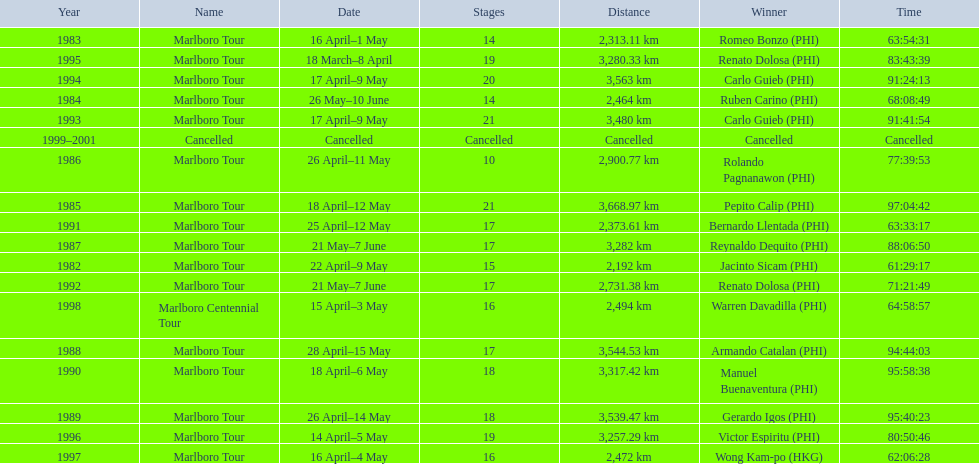Who were all of the winners? Jacinto Sicam (PHI), Romeo Bonzo (PHI), Ruben Carino (PHI), Pepito Calip (PHI), Rolando Pagnanawon (PHI), Reynaldo Dequito (PHI), Armando Catalan (PHI), Gerardo Igos (PHI), Manuel Buenaventura (PHI), Bernardo Llentada (PHI), Renato Dolosa (PHI), Carlo Guieb (PHI), Carlo Guieb (PHI), Renato Dolosa (PHI), Victor Espiritu (PHI), Wong Kam-po (HKG), Warren Davadilla (PHI), Cancelled. When did they compete? 1982, 1983, 1984, 1985, 1986, 1987, 1988, 1989, 1990, 1991, 1992, 1993, 1994, 1995, 1996, 1997, 1998, 1999–2001. What were their finishing times? 61:29:17, 63:54:31, 68:08:49, 97:04:42, 77:39:53, 88:06:50, 94:44:03, 95:40:23, 95:58:38, 63:33:17, 71:21:49, 91:41:54, 91:24:13, 83:43:39, 80:50:46, 62:06:28, 64:58:57, Cancelled. And who won during 1998? Warren Davadilla (PHI). What was his time? 64:58:57. 